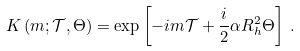Convert formula to latex. <formula><loc_0><loc_0><loc_500><loc_500>K \left ( m ; \mathcal { T } , \Theta \right ) = \exp \left [ - i m \mathcal { T } + \frac { i } { 2 } \alpha R ^ { 2 } _ { h } \Theta \right ] \, .</formula> 